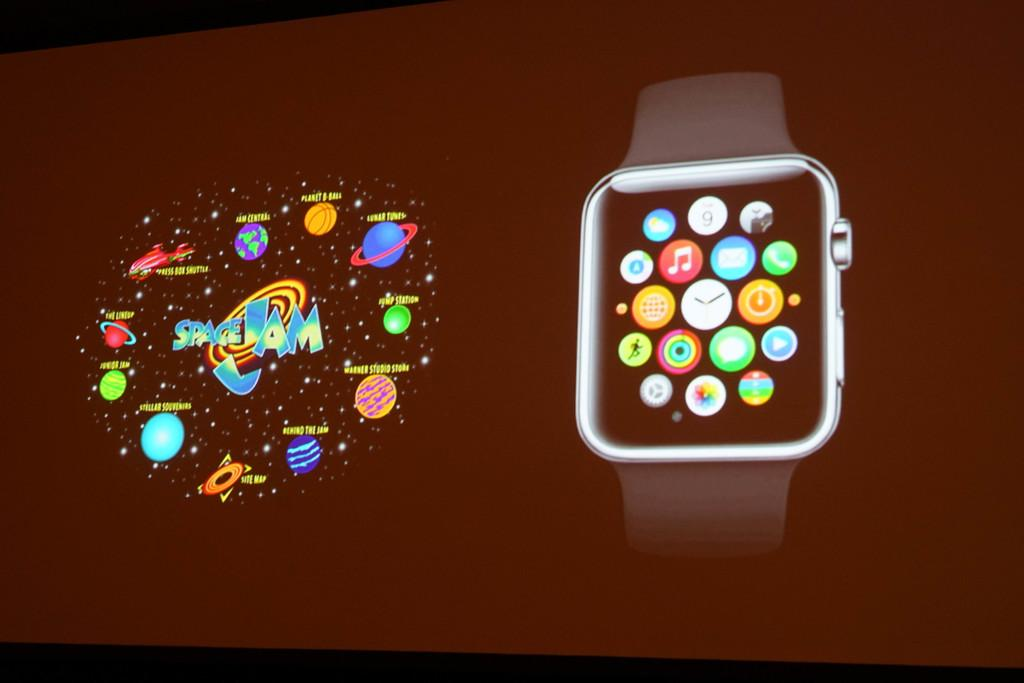<image>
Give a short and clear explanation of the subsequent image. A monitor shows a smart watch and "Space Jam" logo surrounded by planets. 